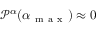Convert formula to latex. <formula><loc_0><loc_0><loc_500><loc_500>\mathcal { P } ^ { \alpha } ( \alpha _ { m a x } ) \approx 0</formula> 